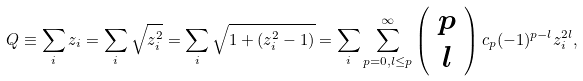<formula> <loc_0><loc_0><loc_500><loc_500>Q \equiv \sum _ { i } z _ { i } = \sum _ { i } \sqrt { z _ { i } ^ { 2 } } = \sum _ { i } \sqrt { 1 + ( z _ { i } ^ { 2 } - 1 ) } = \sum _ { i } \sum _ { p = 0 , l \leq p } ^ { \infty } \left ( \begin{array} { c } p \\ l \end{array} \right ) c _ { p } ( - 1 ) ^ { p - l } z _ { i } ^ { 2 l } ,</formula> 